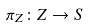Convert formula to latex. <formula><loc_0><loc_0><loc_500><loc_500>\pi _ { Z } \colon Z \rightarrow S</formula> 